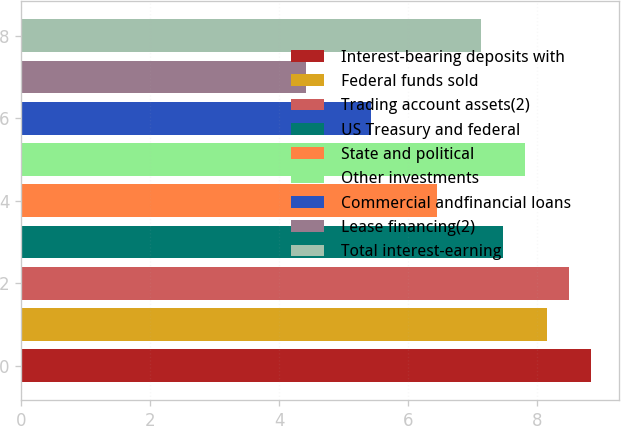Convert chart to OTSL. <chart><loc_0><loc_0><loc_500><loc_500><bar_chart><fcel>Interest-bearing deposits with<fcel>Federal funds sold<fcel>Trading account assets(2)<fcel>US Treasury and federal<fcel>State and political<fcel>Other investments<fcel>Commercial andfinancial loans<fcel>Lease financing(2)<fcel>Total interest-earning<nl><fcel>8.83<fcel>8.15<fcel>8.49<fcel>7.47<fcel>6.45<fcel>7.81<fcel>5.43<fcel>4.41<fcel>7.13<nl></chart> 